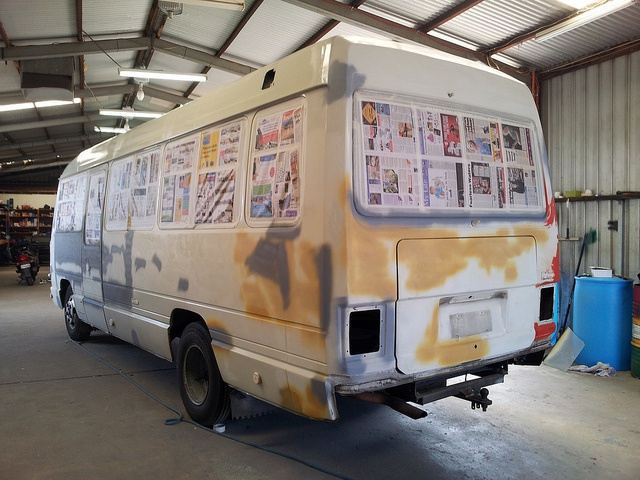Describe the objects in this image and their specific colors. I can see bus in gray, darkgray, tan, and black tones and motorcycle in gray, black, maroon, and darkgray tones in this image. 